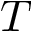<formula> <loc_0><loc_0><loc_500><loc_500>T</formula> 